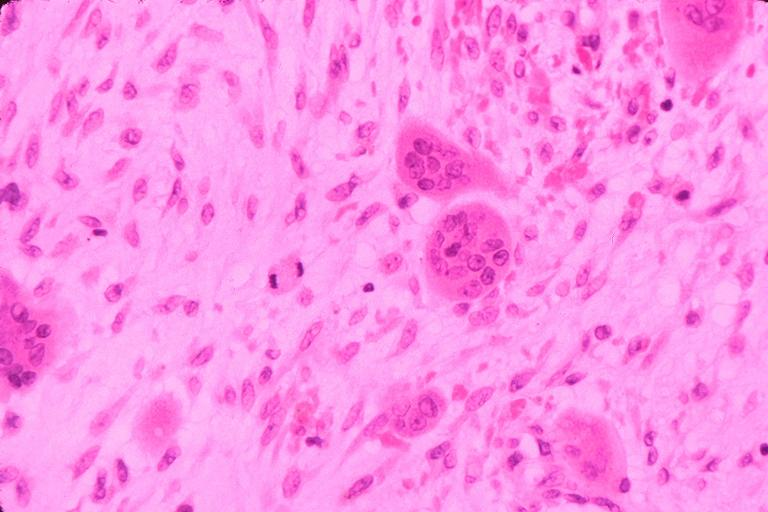what does this image show?
Answer the question using a single word or phrase. Cherubism 